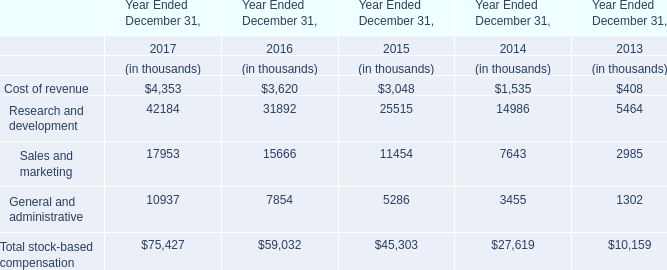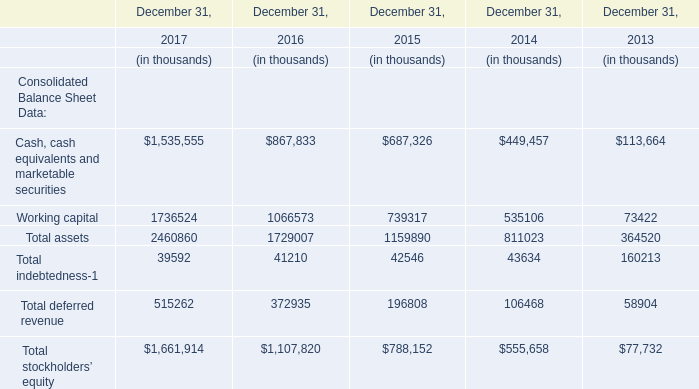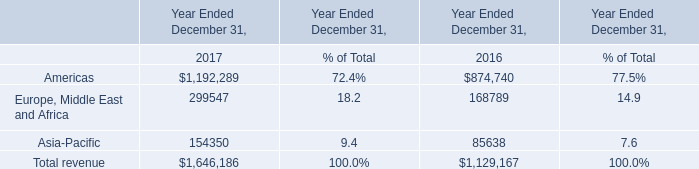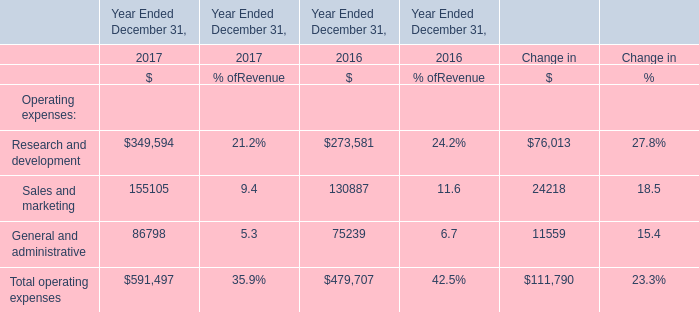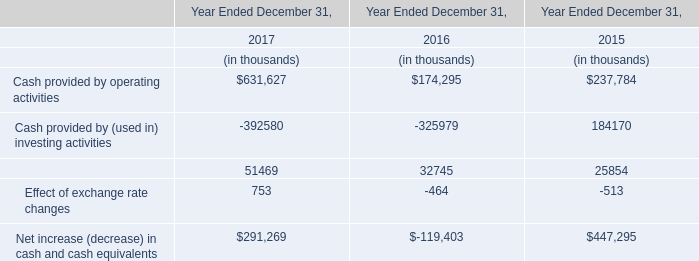What's the growth rate of Sales and marketing in 2017? 
Computations: ((17953 - 15666) / 15666)
Answer: 0.14598. 